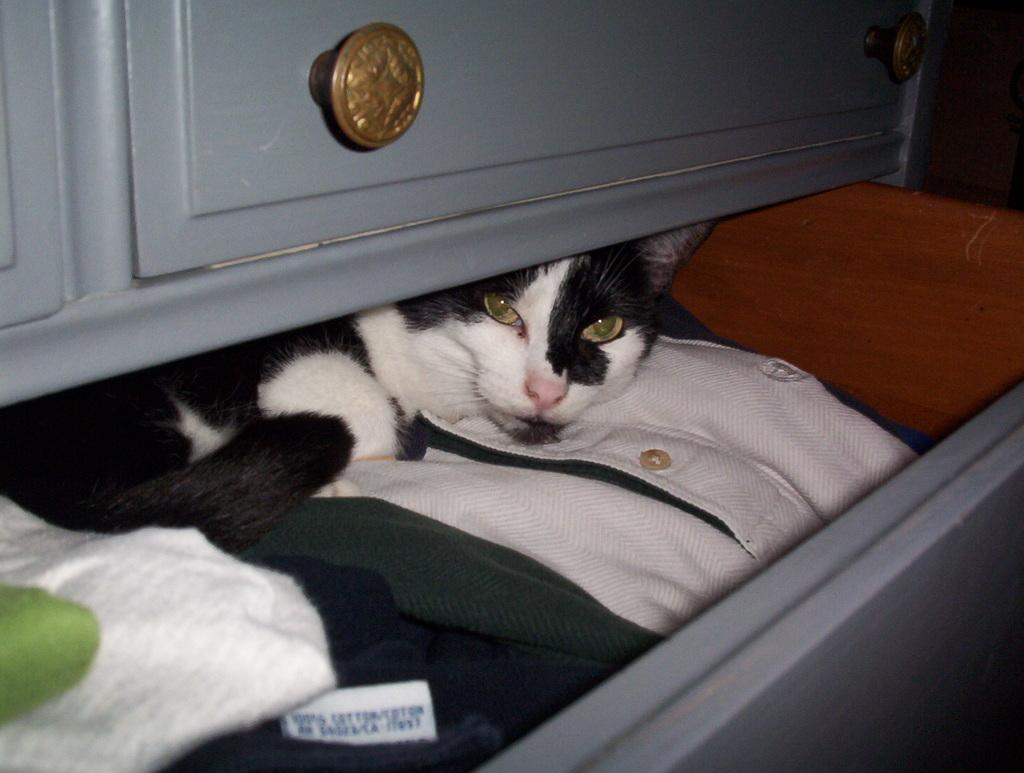What type of animal is present in the image? There is a cat in the image. What can be seen hanging on a rack in the image? There are clothes on a rack in the image. What type of linen is being used to cover the cat's eye in the image? There is no linen or any covering on the cat's eye in the image. How many quarters can be seen on the cat in the image? There are no quarters present in the image; it features a cat and clothes on a rack. 